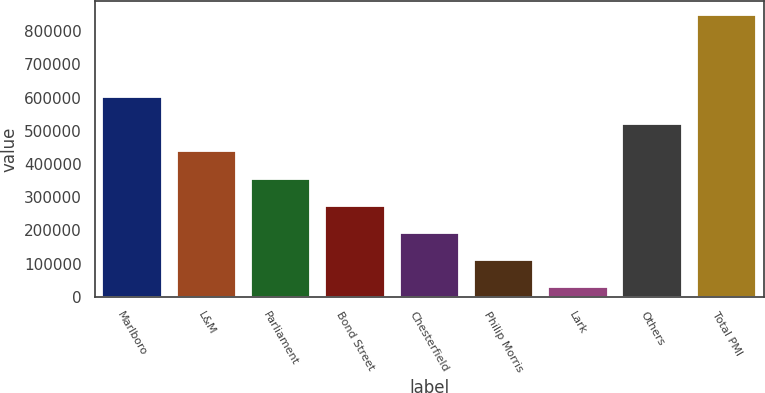Convert chart. <chart><loc_0><loc_0><loc_500><loc_500><bar_chart><fcel>Marlboro<fcel>L&M<fcel>Parliament<fcel>Bond Street<fcel>Chesterfield<fcel>Philip Morris<fcel>Lark<fcel>Others<fcel>Total PMI<nl><fcel>601737<fcel>438049<fcel>356205<fcel>274361<fcel>192516<fcel>110672<fcel>28828<fcel>519893<fcel>847270<nl></chart> 